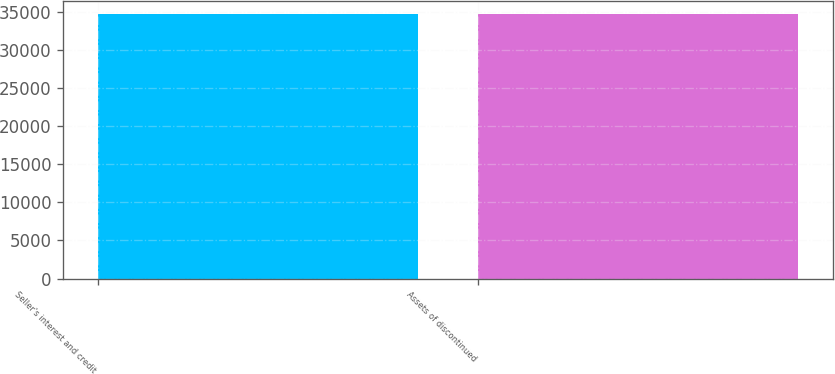Convert chart to OTSL. <chart><loc_0><loc_0><loc_500><loc_500><bar_chart><fcel>Seller's interest and credit<fcel>Assets of discontinued<nl><fcel>34623<fcel>34623.1<nl></chart> 